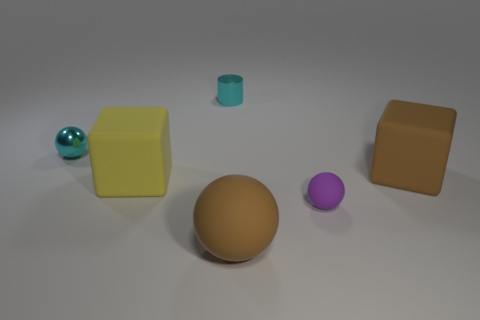The big sphere to the left of the small object that is on the right side of the cyan shiny thing behind the cyan sphere is made of what material?
Offer a terse response. Rubber. How many green matte objects have the same shape as the purple object?
Keep it short and to the point. 0. How big is the block to the left of the matte ball in front of the small purple matte object?
Your answer should be compact. Large. Do the matte thing to the right of the small purple sphere and the cube left of the cylinder have the same color?
Offer a terse response. No. There is a large ball that is to the left of the rubber block on the right side of the big yellow cube; what number of brown things are in front of it?
Offer a very short reply. 0. What number of things are both in front of the brown matte block and to the left of the brown ball?
Offer a terse response. 1. Are there more big spheres that are on the right side of the yellow thing than purple cubes?
Your answer should be compact. Yes. How many purple things have the same size as the yellow matte thing?
Keep it short and to the point. 0. The sphere that is the same color as the small cylinder is what size?
Make the answer very short. Small. What number of big objects are brown blocks or cyan metallic objects?
Keep it short and to the point. 1. 